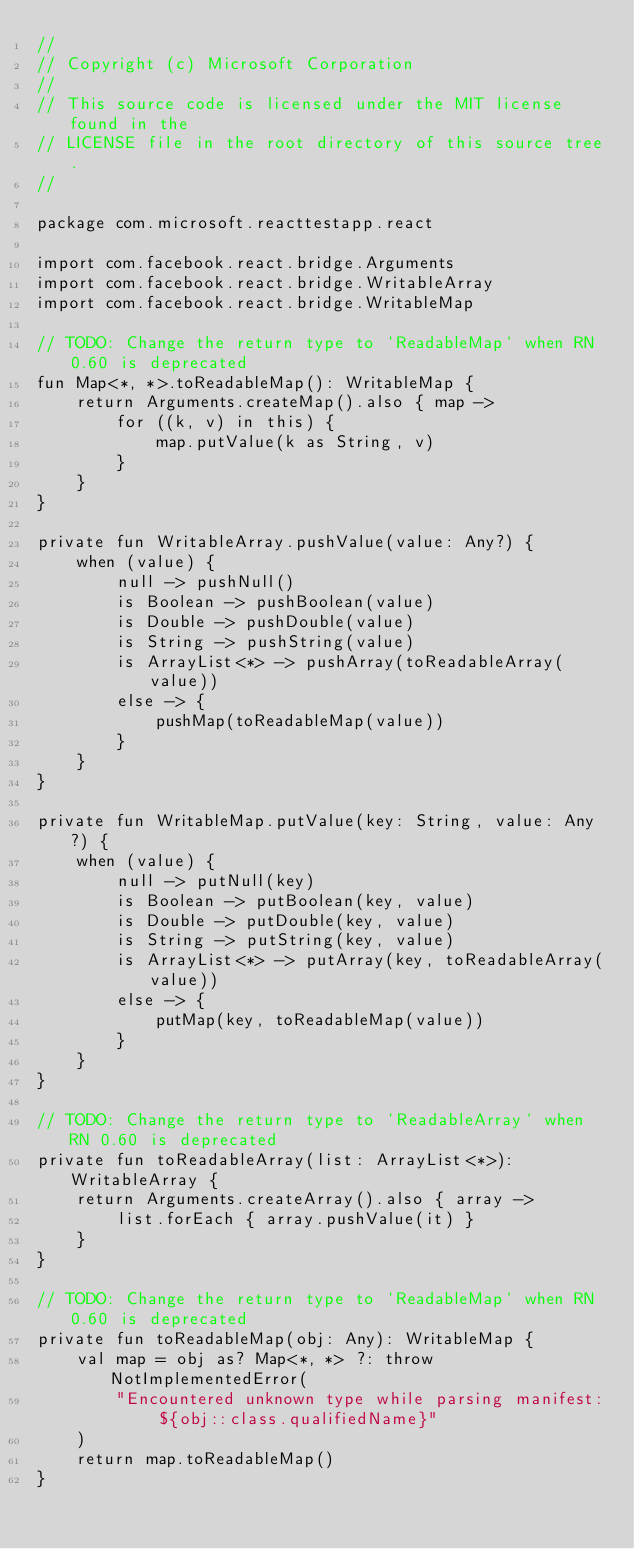Convert code to text. <code><loc_0><loc_0><loc_500><loc_500><_Kotlin_>//
// Copyright (c) Microsoft Corporation
//
// This source code is licensed under the MIT license found in the
// LICENSE file in the root directory of this source tree.
//

package com.microsoft.reacttestapp.react

import com.facebook.react.bridge.Arguments
import com.facebook.react.bridge.WritableArray
import com.facebook.react.bridge.WritableMap

// TODO: Change the return type to `ReadableMap` when RN 0.60 is deprecated
fun Map<*, *>.toReadableMap(): WritableMap {
    return Arguments.createMap().also { map ->
        for ((k, v) in this) {
            map.putValue(k as String, v)
        }
    }
}

private fun WritableArray.pushValue(value: Any?) {
    when (value) {
        null -> pushNull()
        is Boolean -> pushBoolean(value)
        is Double -> pushDouble(value)
        is String -> pushString(value)
        is ArrayList<*> -> pushArray(toReadableArray(value))
        else -> {
            pushMap(toReadableMap(value))
        }
    }
}

private fun WritableMap.putValue(key: String, value: Any?) {
    when (value) {
        null -> putNull(key)
        is Boolean -> putBoolean(key, value)
        is Double -> putDouble(key, value)
        is String -> putString(key, value)
        is ArrayList<*> -> putArray(key, toReadableArray(value))
        else -> {
            putMap(key, toReadableMap(value))
        }
    }
}

// TODO: Change the return type to `ReadableArray` when RN 0.60 is deprecated
private fun toReadableArray(list: ArrayList<*>): WritableArray {
    return Arguments.createArray().also { array ->
        list.forEach { array.pushValue(it) }
    }
}

// TODO: Change the return type to `ReadableMap` when RN 0.60 is deprecated
private fun toReadableMap(obj: Any): WritableMap {
    val map = obj as? Map<*, *> ?: throw NotImplementedError(
        "Encountered unknown type while parsing manifest: ${obj::class.qualifiedName}"
    )
    return map.toReadableMap()
}
</code> 